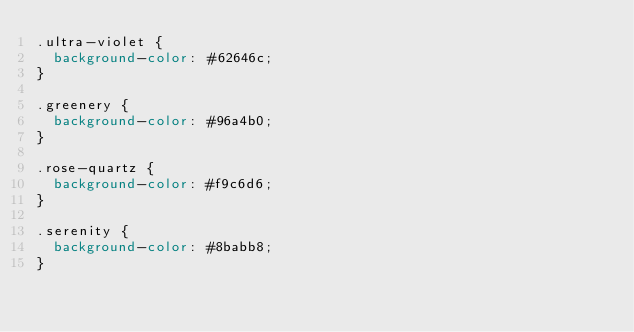<code> <loc_0><loc_0><loc_500><loc_500><_CSS_>.ultra-violet {
  background-color: #62646c;
}

.greenery {
  background-color: #96a4b0;
}

.rose-quartz {
  background-color: #f9c6d6;
}

.serenity {
  background-color: #8babb8;
}
</code> 